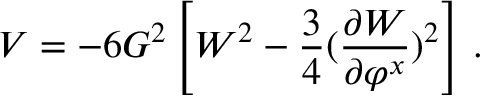<formula> <loc_0><loc_0><loc_500><loc_500>V = - 6 G ^ { 2 } \left [ W ^ { 2 } - \frac { 3 } { 4 } ( { \frac { \partial W } { \partial \varphi ^ { x } } } ) ^ { 2 } \right ] \, .</formula> 